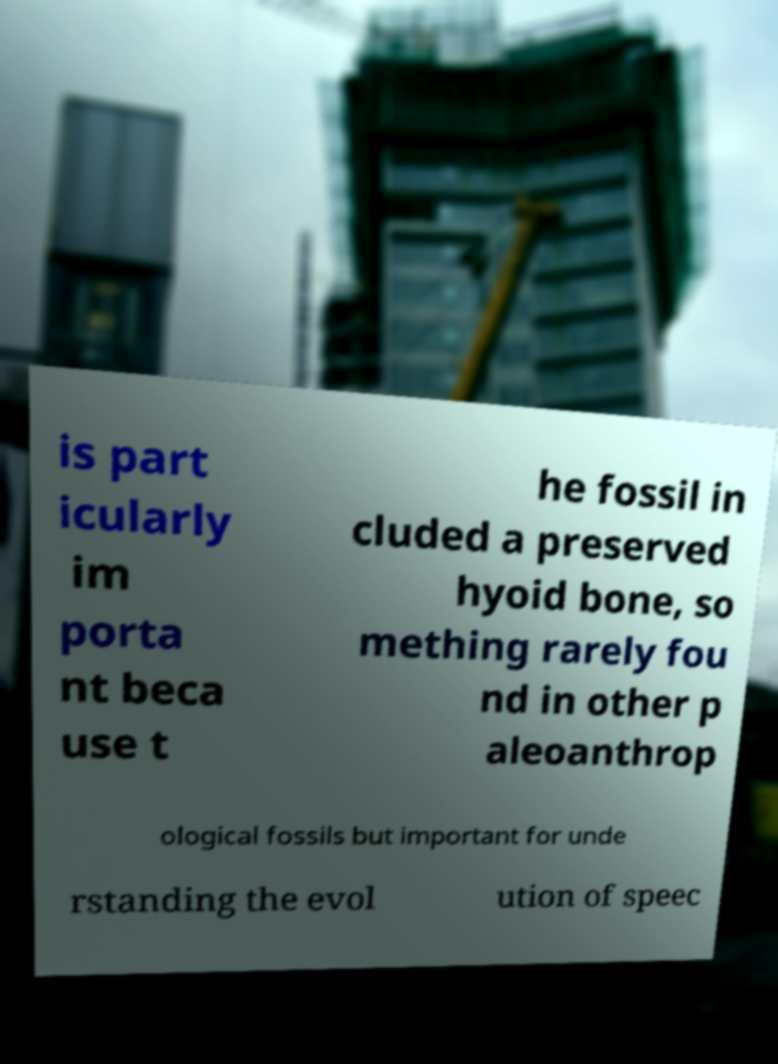Please read and relay the text visible in this image. What does it say? is part icularly im porta nt beca use t he fossil in cluded a preserved hyoid bone, so mething rarely fou nd in other p aleoanthrop ological fossils but important for unde rstanding the evol ution of speec 